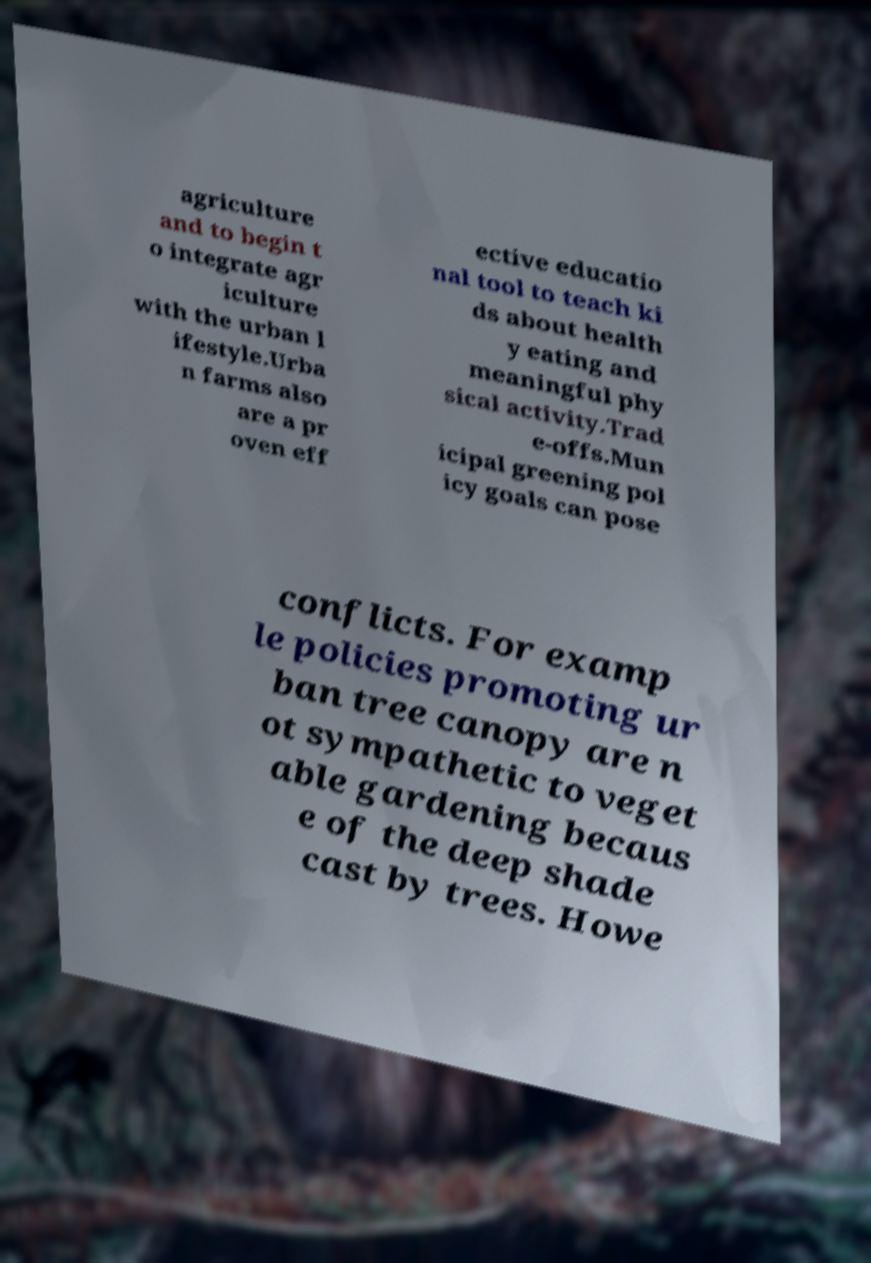For documentation purposes, I need the text within this image transcribed. Could you provide that? agriculture and to begin t o integrate agr iculture with the urban l ifestyle.Urba n farms also are a pr oven eff ective educatio nal tool to teach ki ds about health y eating and meaningful phy sical activity.Trad e-offs.Mun icipal greening pol icy goals can pose conflicts. For examp le policies promoting ur ban tree canopy are n ot sympathetic to veget able gardening becaus e of the deep shade cast by trees. Howe 